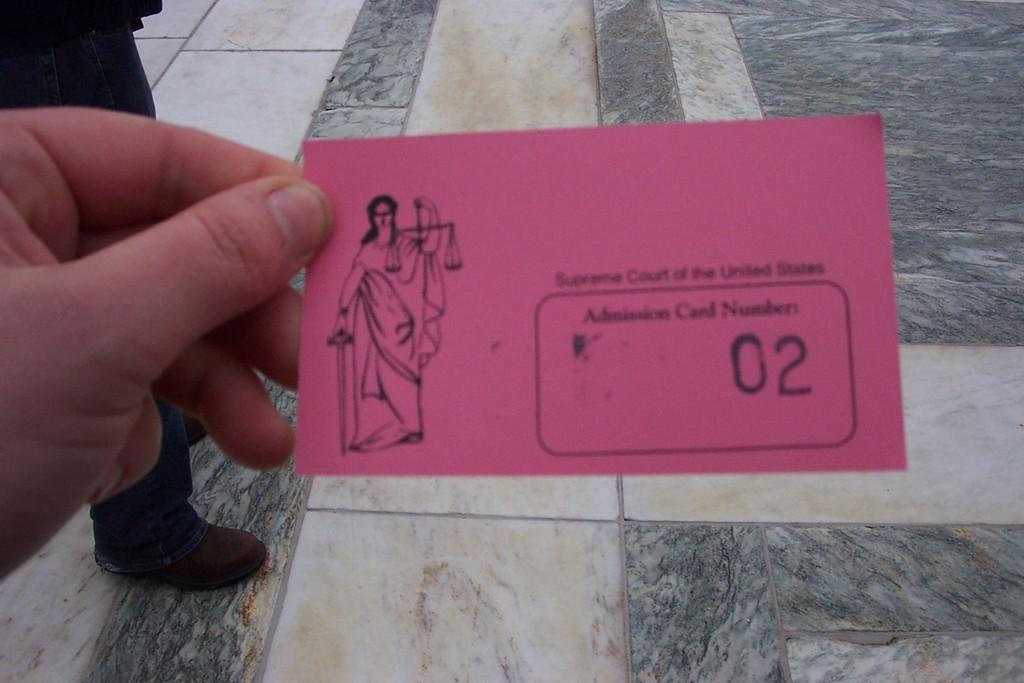What is the position of the first person in the image? There is a person standing on the floor in the image. How many people are present in the image? There are two people in the image. What is the second person holding? The second person is holding a paper. What type of locket is the person wearing in the image? There is no locket visible on either person in the image. What time of day is it in the image? The time of day cannot be determined from the image. 